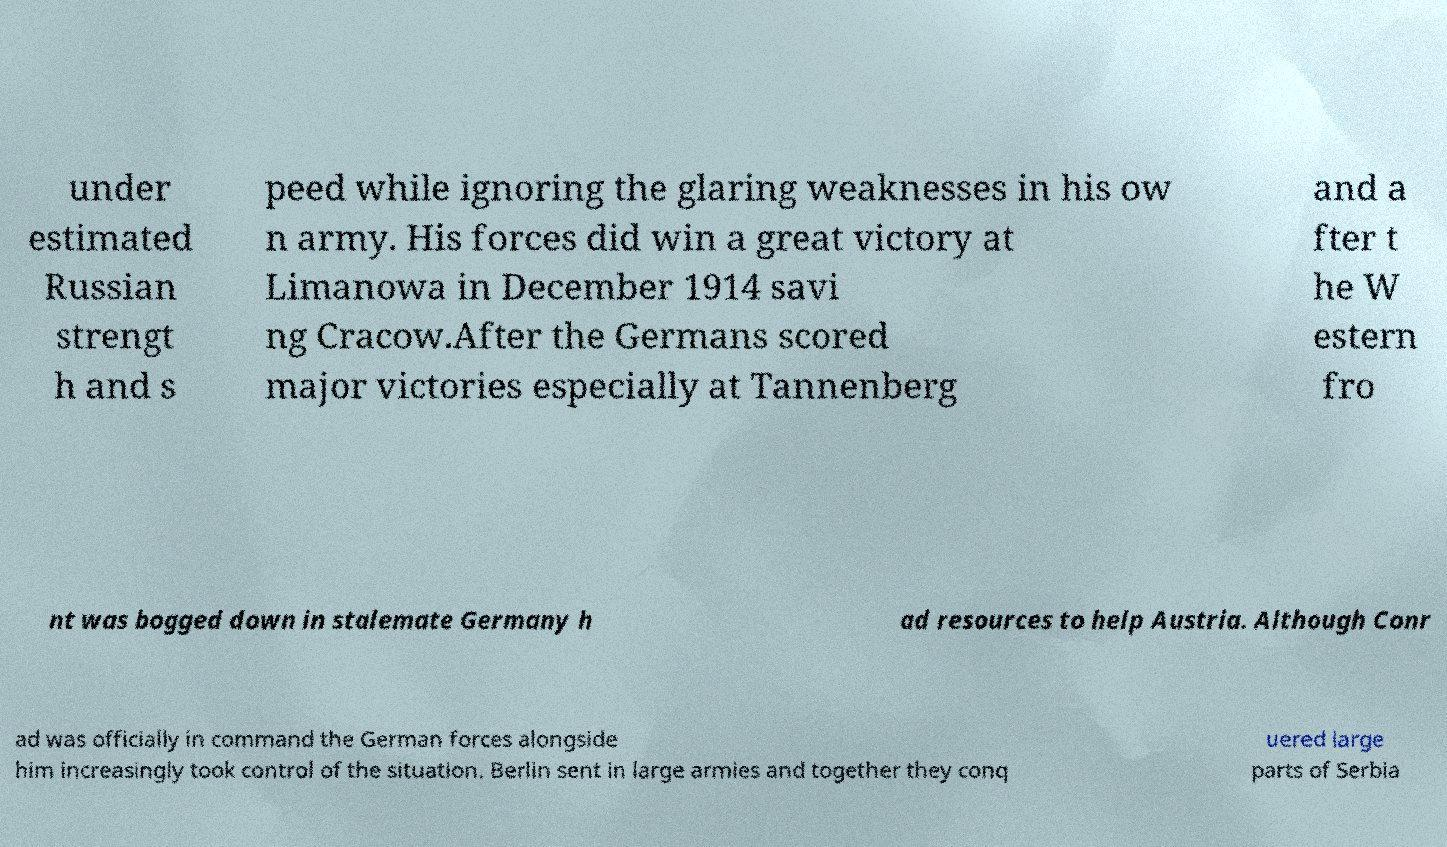For documentation purposes, I need the text within this image transcribed. Could you provide that? under estimated Russian strengt h and s peed while ignoring the glaring weaknesses in his ow n army. His forces did win a great victory at Limanowa in December 1914 savi ng Cracow.After the Germans scored major victories especially at Tannenberg and a fter t he W estern fro nt was bogged down in stalemate Germany h ad resources to help Austria. Although Conr ad was officially in command the German forces alongside him increasingly took control of the situation. Berlin sent in large armies and together they conq uered large parts of Serbia 